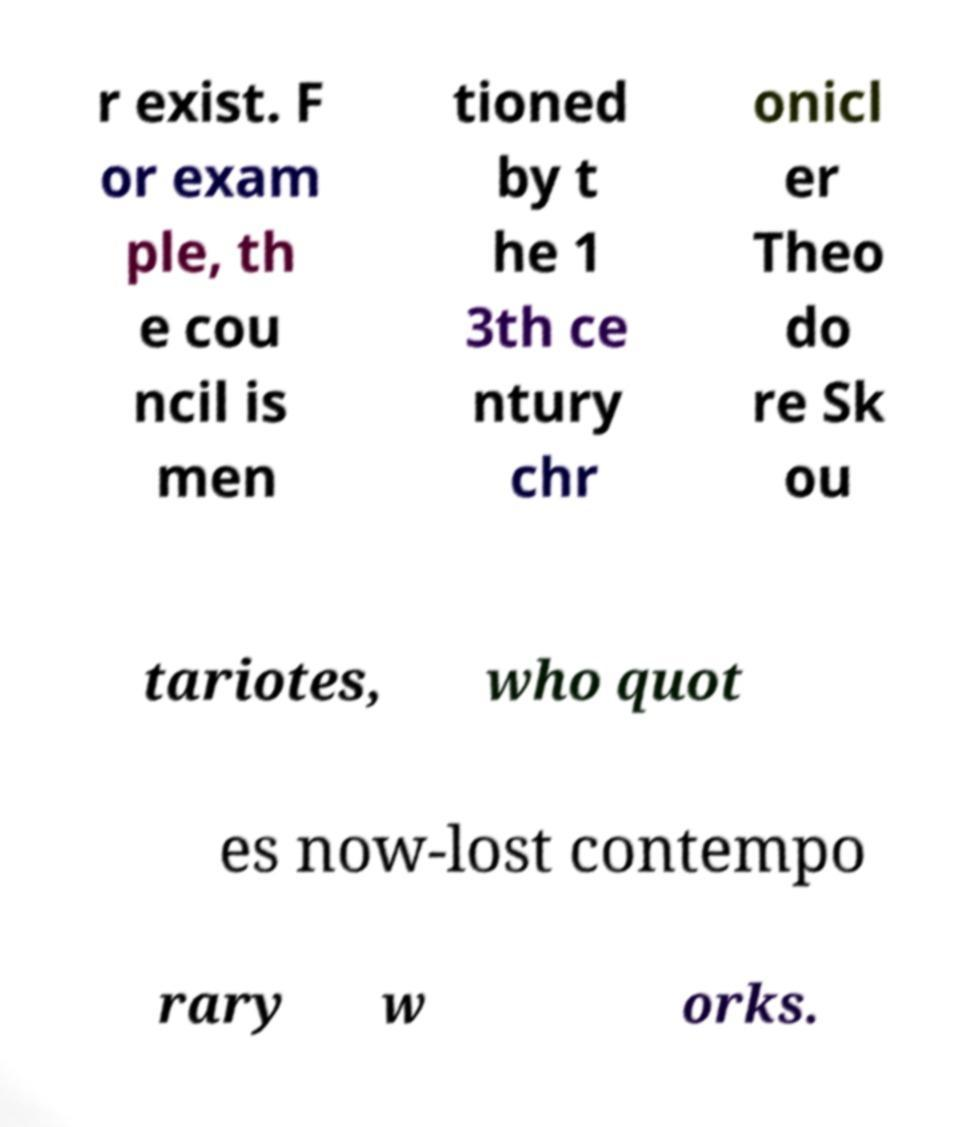Can you accurately transcribe the text from the provided image for me? r exist. F or exam ple, th e cou ncil is men tioned by t he 1 3th ce ntury chr onicl er Theo do re Sk ou tariotes, who quot es now-lost contempo rary w orks. 